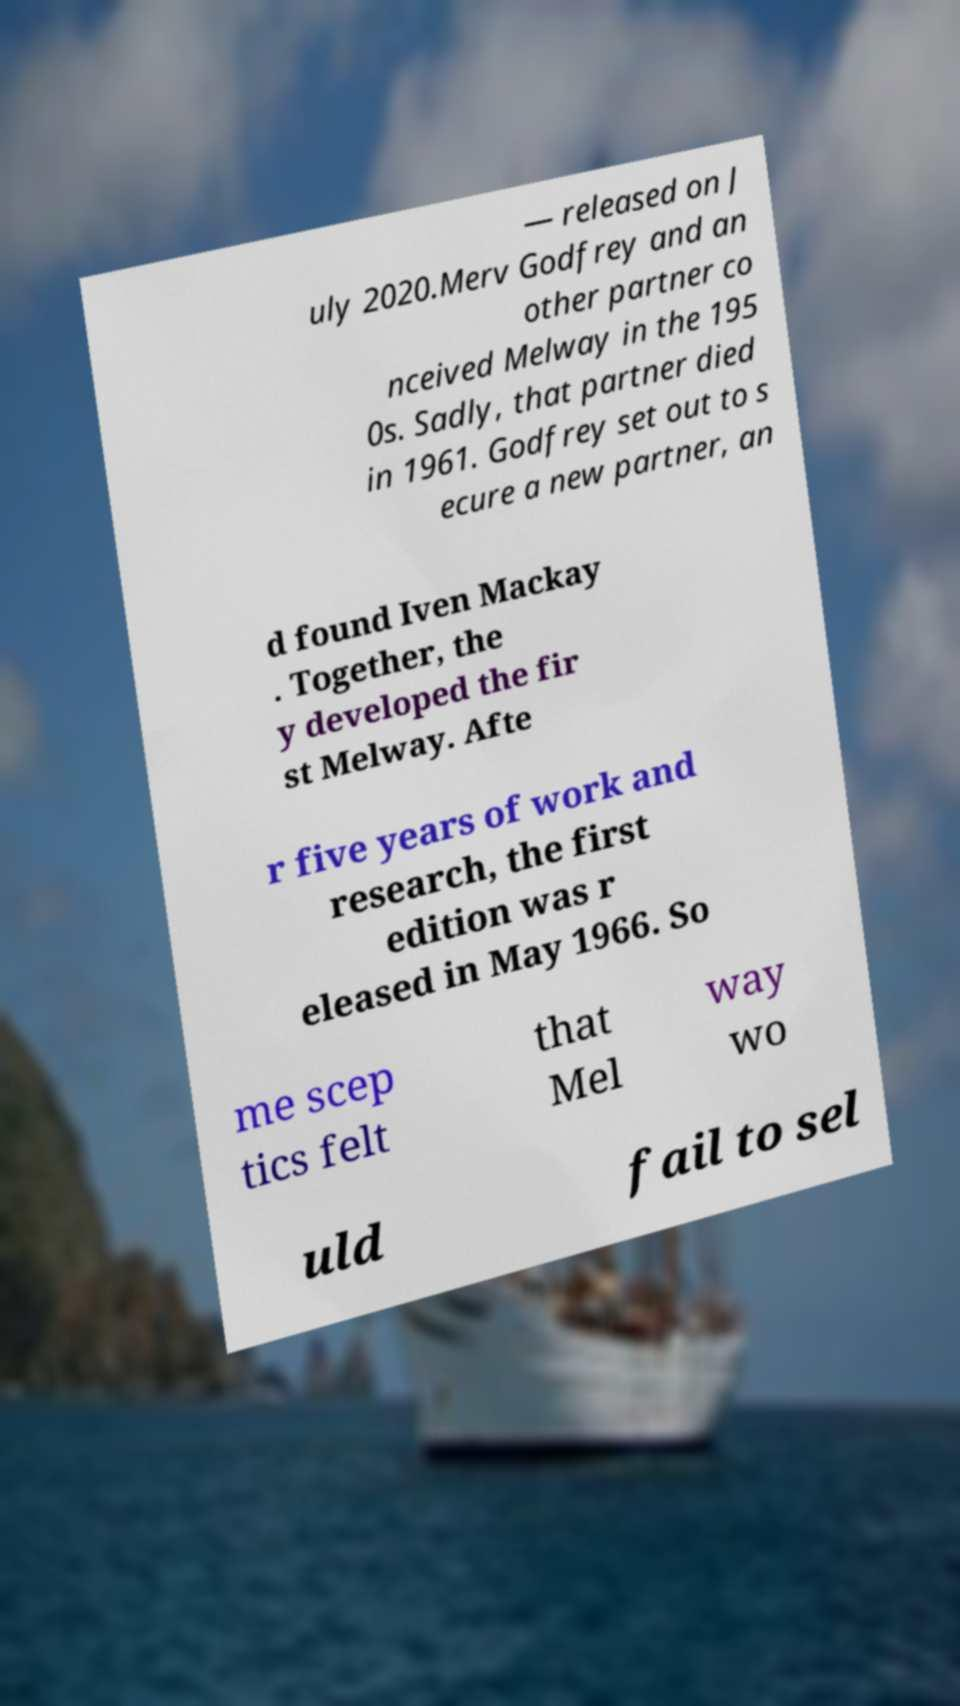I need the written content from this picture converted into text. Can you do that? — released on J uly 2020.Merv Godfrey and an other partner co nceived Melway in the 195 0s. Sadly, that partner died in 1961. Godfrey set out to s ecure a new partner, an d found Iven Mackay . Together, the y developed the fir st Melway. Afte r five years of work and research, the first edition was r eleased in May 1966. So me scep tics felt that Mel way wo uld fail to sel 